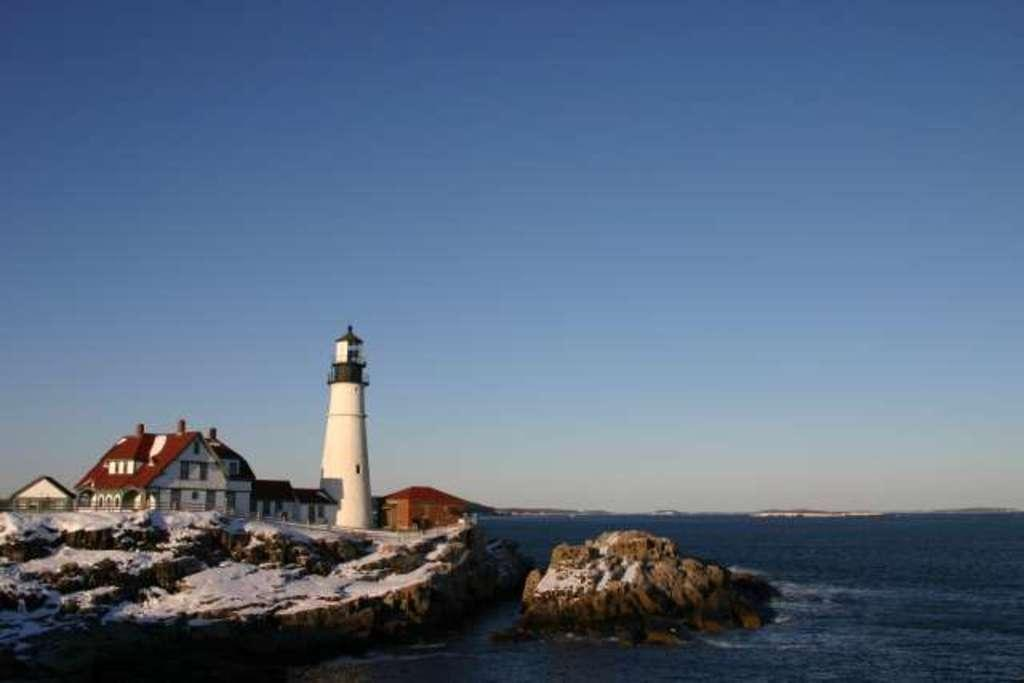What is in the foreground of the image? There is water and rocks in the foreground of the image. What can be seen in the background of the image? There is a lighthouse, houses, and a railing in the background of the image. What is visible at the top of the image? The sky is visible at the top of the image. How many tickets are needed to access the lighthouse in the image? There is no mention of tickets or access to the lighthouse in the image. What type of kettle is present in the image? There is no kettle present in the image. 